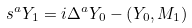Convert formula to latex. <formula><loc_0><loc_0><loc_500><loc_500>s ^ { a } Y _ { 1 } = i \Delta ^ { a } Y _ { 0 } - \left ( Y _ { 0 } , M _ { 1 } \right )</formula> 